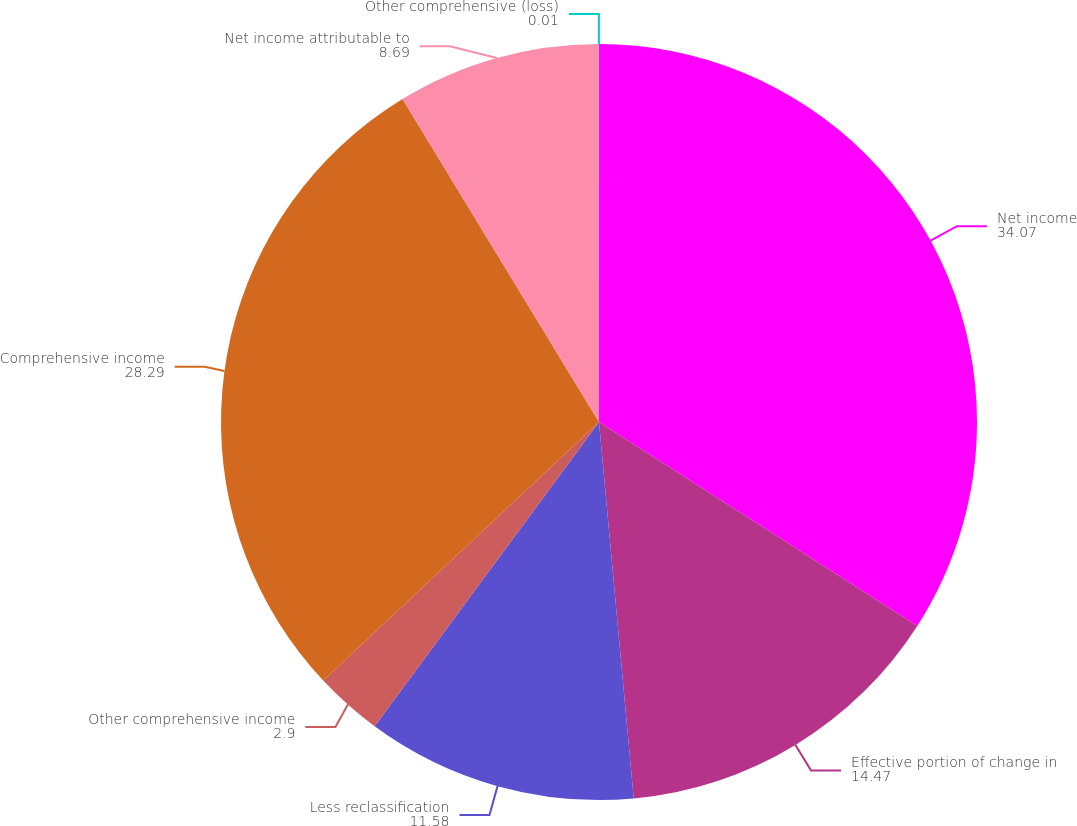Convert chart. <chart><loc_0><loc_0><loc_500><loc_500><pie_chart><fcel>Net income<fcel>Effective portion of change in<fcel>Less reclassification<fcel>Other comprehensive income<fcel>Comprehensive income<fcel>Net income attributable to<fcel>Other comprehensive (loss)<nl><fcel>34.07%<fcel>14.47%<fcel>11.58%<fcel>2.9%<fcel>28.29%<fcel>8.69%<fcel>0.01%<nl></chart> 